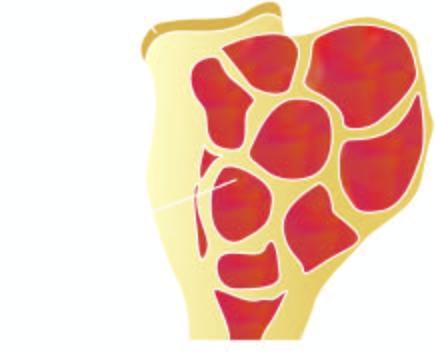what is expanded in the region of epiphysis?
Answer the question using a single word or phrase. End of the long bone 